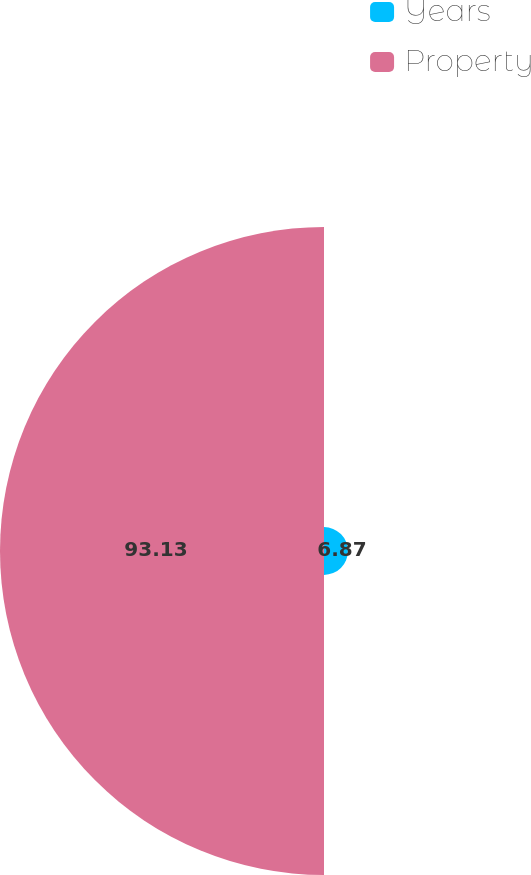<chart> <loc_0><loc_0><loc_500><loc_500><pie_chart><fcel>Years<fcel>Property<nl><fcel>6.87%<fcel>93.13%<nl></chart> 